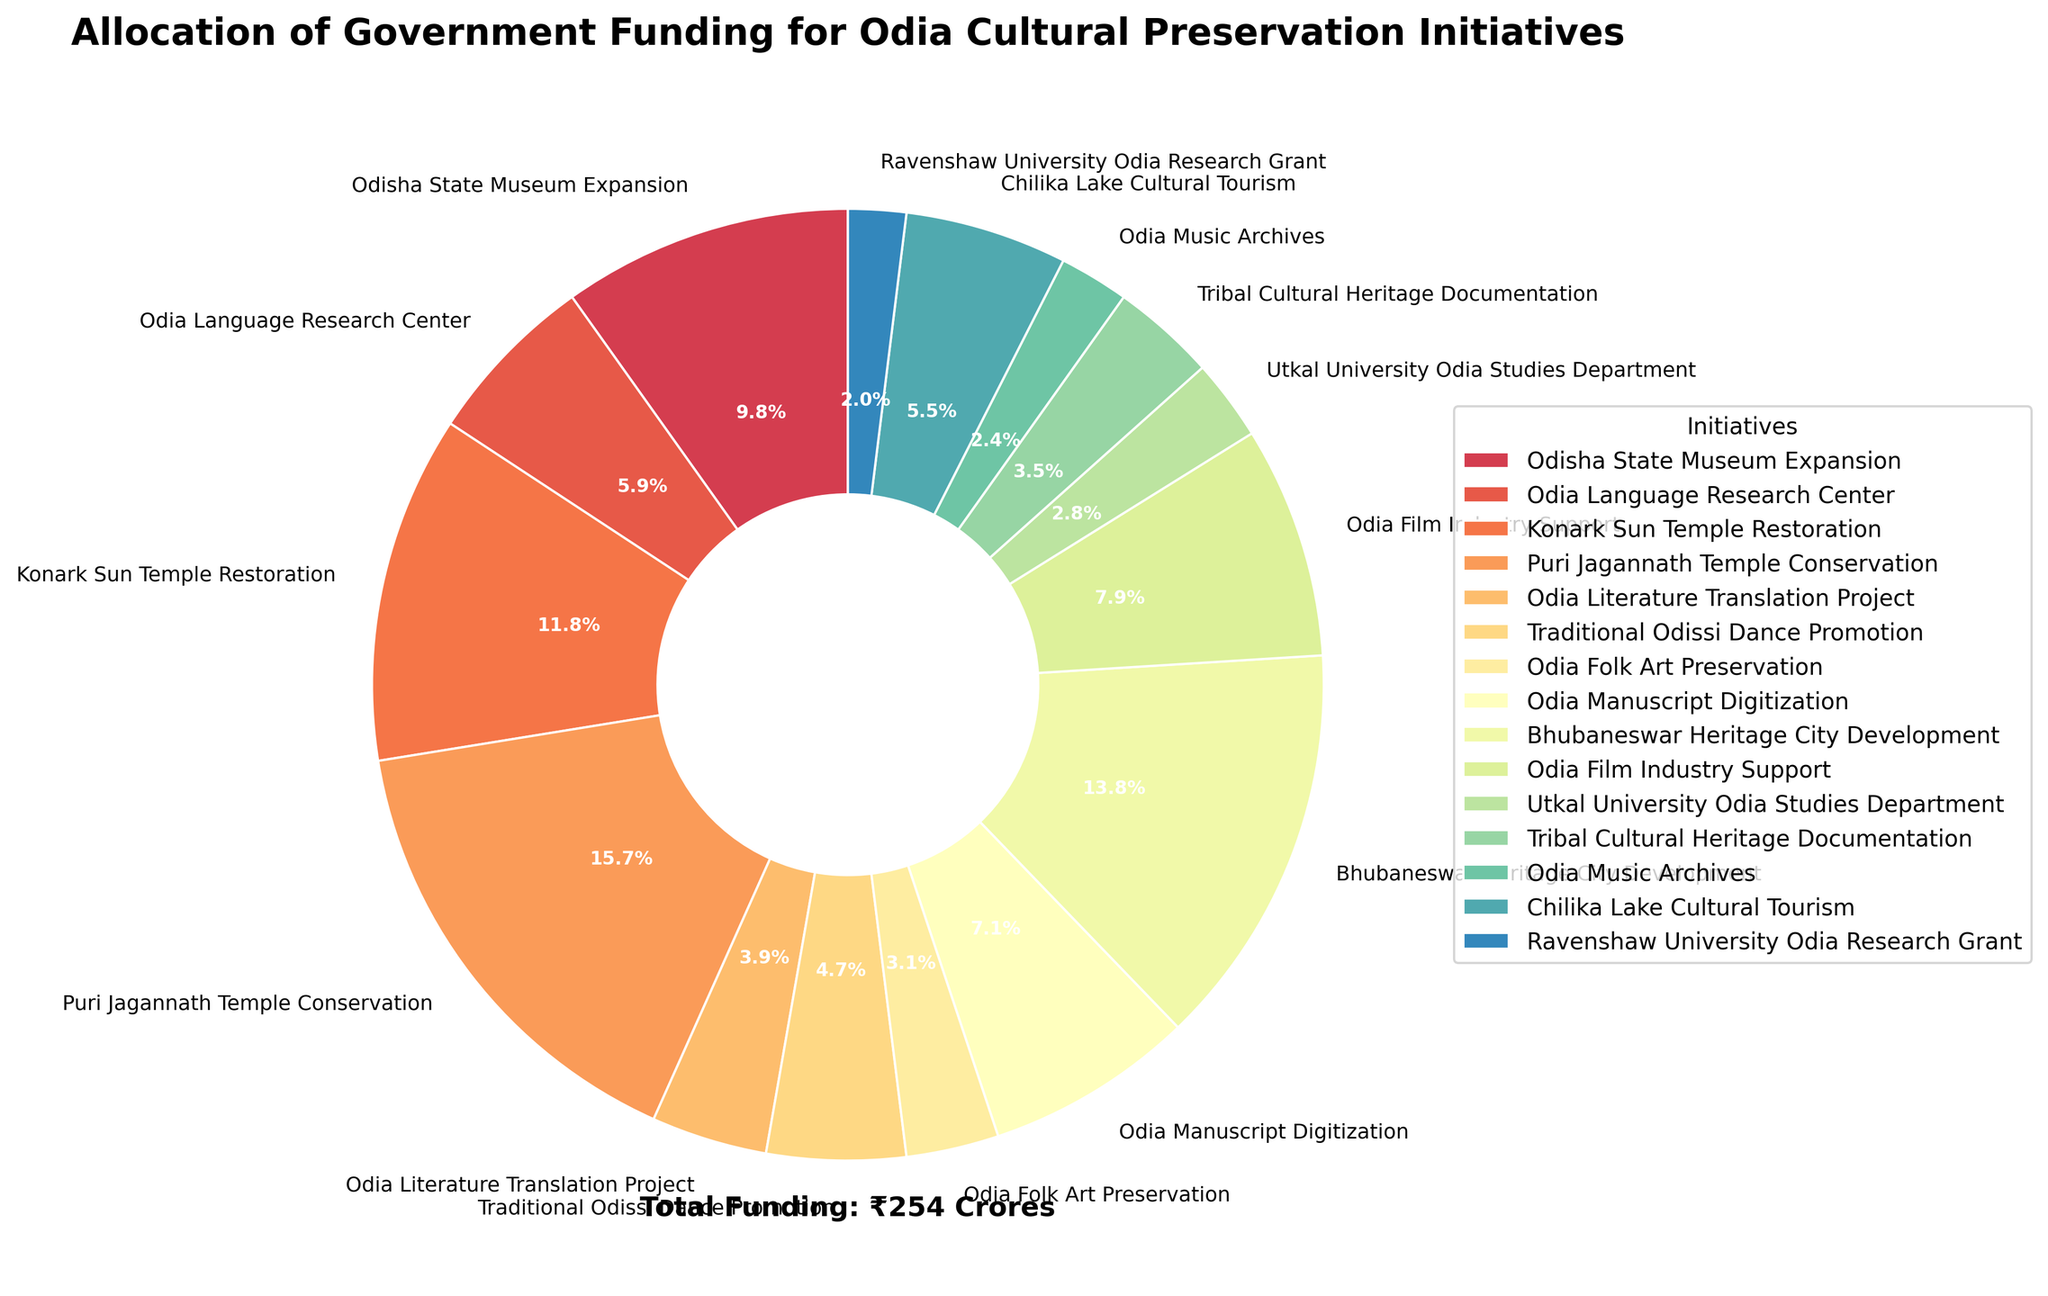How many initiatives received funding greater than ₹20 crores? There are four initiatives that received funding greater than ₹20 crores. These initiatives are the Konark Sun Temple Restoration (₹30 crores), Puri Jagannath Temple Conservation (₹40 crores), Bhubaneswar Heritage City Development (₹35 crores), and Odisha State Museum Expansion (₹25 crores).
Answer: 4 Which initiative received the least amount of funding and how much did it receive? The initiative that received the least amount of funding is the Ravenshaw University Odia Research Grant, with funding of ₹5 crores.
Answer: Ravenshaw University Odia Research Grant, ₹5 crores What percentage of the total funding is allocated to the Puri Jagannath Temple Conservation? The total funding is ₹254 crores. The Puri Jagannath Temple Conservation received ₹40 crores. To find the percentage, divide the funding for the Puri Jagannath Temple Conservation by the total funding and multiply by 100.
(40/254) x 100 = 15.7%
Answer: 15.7% Compare the funding of the Traditional Odissi Dance Promotion to the Odia Language Research Center. Which received more funding and by how much? The Traditional Odissi Dance Promotion received ₹12 crores, while the Odia Language Research Center received ₹15 crores. The Odia Language Research Center received more funding by ₹3 crores.
15 - 12 = 3
Answer: Odia Language Research Center, ₹3 crores What is the combined funding for Chilika Lake Cultural Tourism and Odia Folk Art Preservation? The Chilika Lake Cultural Tourism initiative received ₹14 crores and the Odia Folk Art Preservation received ₹8 crores. Adding these amounts gives us:
14 + 8 = ₹22 crores
Answer: ₹22 crores Which two initiatives have the closest funding amounts, and what is the difference? The Traditional Odissi Dance Promotion received ₹12 crores and Chilika Lake Cultural Tourism received ₹14 crores. The difference between these two amounts is:
14 - 12 = ₹2 crores
Answer: Traditional Odissi Dance Promotion and Chilika Lake Cultural Tourism, ₹2 crores How does the funding for the Odisha State Museum Expansion visually compare to that of the Odia Language Research Center in the pie chart? In the pie chart, the wedge representing the Odisha State Museum Expansion is visually larger than that of the Odia Language Research Center, indicating that the former received more funding. Also, the Odisha State Museum Expansion wedge is colored distinctively to make it easily identifiable.
Answer: Odisha State Museum Expansion is larger visually 